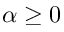<formula> <loc_0><loc_0><loc_500><loc_500>\alpha \geq 0</formula> 